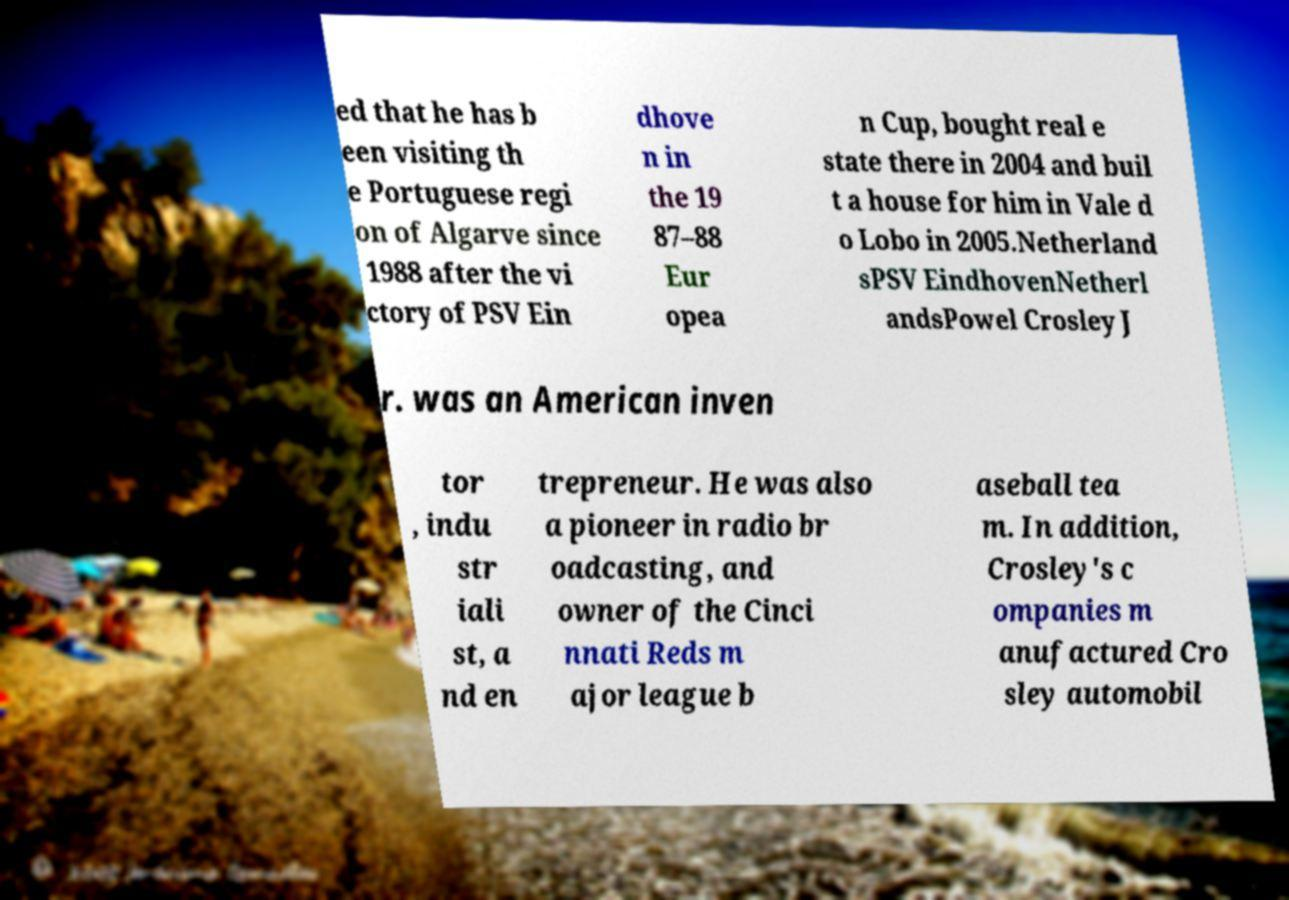Can you read and provide the text displayed in the image?This photo seems to have some interesting text. Can you extract and type it out for me? ed that he has b een visiting th e Portuguese regi on of Algarve since 1988 after the vi ctory of PSV Ein dhove n in the 19 87–88 Eur opea n Cup, bought real e state there in 2004 and buil t a house for him in Vale d o Lobo in 2005.Netherland sPSV EindhovenNetherl andsPowel Crosley J r. was an American inven tor , indu str iali st, a nd en trepreneur. He was also a pioneer in radio br oadcasting, and owner of the Cinci nnati Reds m ajor league b aseball tea m. In addition, Crosley's c ompanies m anufactured Cro sley automobil 